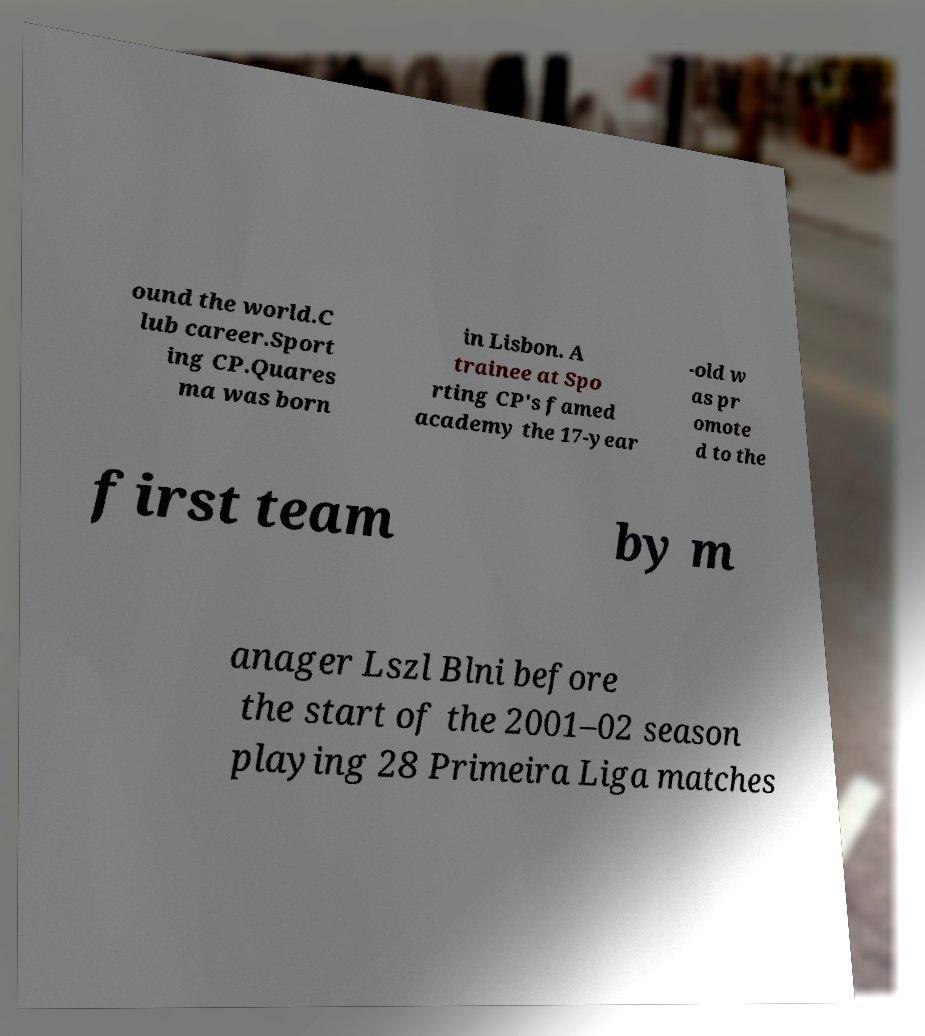For documentation purposes, I need the text within this image transcribed. Could you provide that? ound the world.C lub career.Sport ing CP.Quares ma was born in Lisbon. A trainee at Spo rting CP's famed academy the 17-year -old w as pr omote d to the first team by m anager Lszl Blni before the start of the 2001–02 season playing 28 Primeira Liga matches 